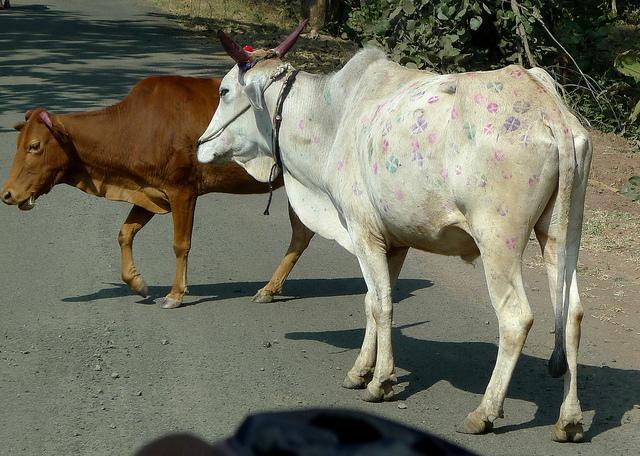How many cows are on the road?
Give a very brief answer. 2. How many cows can be seen?
Give a very brief answer. 2. 